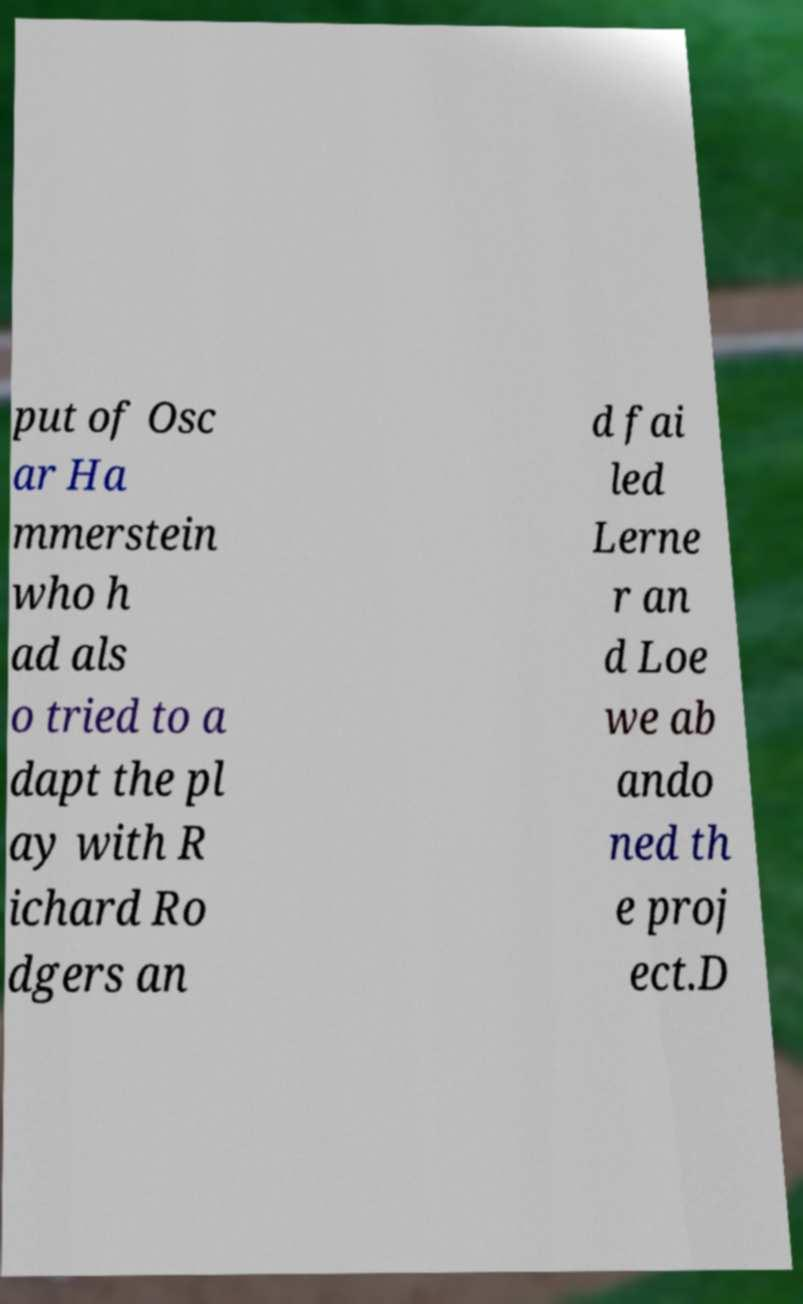Please read and relay the text visible in this image. What does it say? put of Osc ar Ha mmerstein who h ad als o tried to a dapt the pl ay with R ichard Ro dgers an d fai led Lerne r an d Loe we ab ando ned th e proj ect.D 